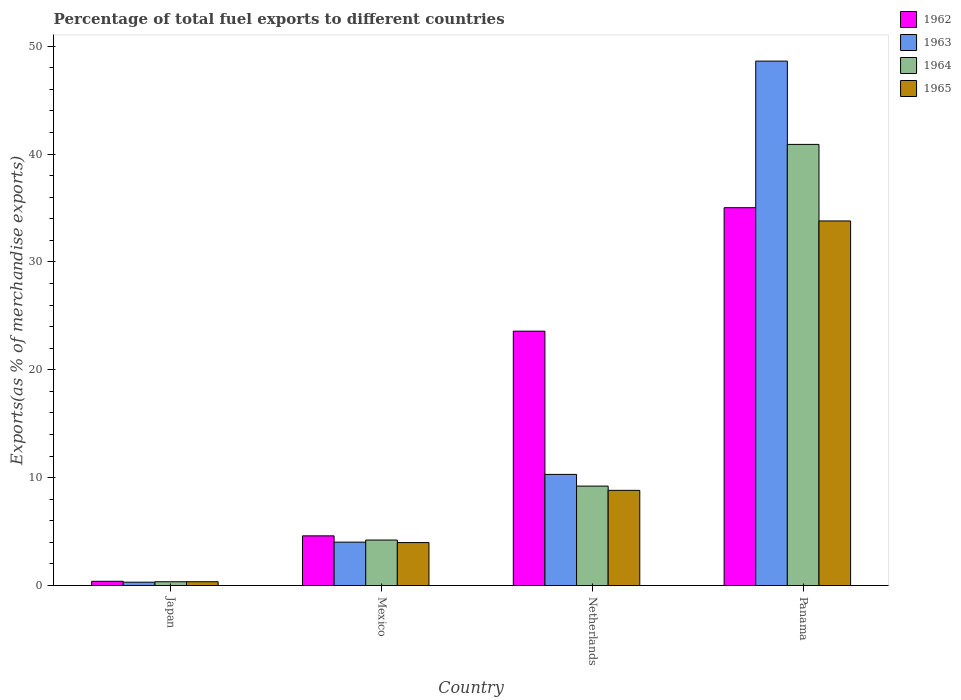How many groups of bars are there?
Offer a terse response. 4. Are the number of bars per tick equal to the number of legend labels?
Give a very brief answer. Yes. How many bars are there on the 3rd tick from the left?
Make the answer very short. 4. How many bars are there on the 4th tick from the right?
Keep it short and to the point. 4. What is the label of the 2nd group of bars from the left?
Your answer should be very brief. Mexico. What is the percentage of exports to different countries in 1965 in Panama?
Your answer should be compact. 33.8. Across all countries, what is the maximum percentage of exports to different countries in 1962?
Your response must be concise. 35.03. Across all countries, what is the minimum percentage of exports to different countries in 1962?
Offer a terse response. 0.4. In which country was the percentage of exports to different countries in 1965 maximum?
Ensure brevity in your answer.  Panama. What is the total percentage of exports to different countries in 1962 in the graph?
Offer a very short reply. 63.62. What is the difference between the percentage of exports to different countries in 1964 in Japan and that in Panama?
Provide a short and direct response. -40.54. What is the difference between the percentage of exports to different countries in 1965 in Japan and the percentage of exports to different countries in 1964 in Netherlands?
Provide a short and direct response. -8.86. What is the average percentage of exports to different countries in 1964 per country?
Make the answer very short. 13.67. What is the difference between the percentage of exports to different countries of/in 1964 and percentage of exports to different countries of/in 1962 in Panama?
Your answer should be very brief. 5.87. In how many countries, is the percentage of exports to different countries in 1963 greater than 22 %?
Your response must be concise. 1. What is the ratio of the percentage of exports to different countries in 1962 in Mexico to that in Netherlands?
Your answer should be compact. 0.2. Is the percentage of exports to different countries in 1965 in Japan less than that in Mexico?
Make the answer very short. Yes. Is the difference between the percentage of exports to different countries in 1964 in Japan and Netherlands greater than the difference between the percentage of exports to different countries in 1962 in Japan and Netherlands?
Your answer should be very brief. Yes. What is the difference between the highest and the second highest percentage of exports to different countries in 1962?
Make the answer very short. 30.42. What is the difference between the highest and the lowest percentage of exports to different countries in 1962?
Provide a succinct answer. 34.63. In how many countries, is the percentage of exports to different countries in 1963 greater than the average percentage of exports to different countries in 1963 taken over all countries?
Provide a short and direct response. 1. What does the 3rd bar from the left in Netherlands represents?
Give a very brief answer. 1964. What does the 4th bar from the right in Japan represents?
Provide a short and direct response. 1962. How many countries are there in the graph?
Your answer should be very brief. 4. Are the values on the major ticks of Y-axis written in scientific E-notation?
Offer a very short reply. No. Does the graph contain grids?
Provide a succinct answer. No. Where does the legend appear in the graph?
Make the answer very short. Top right. How many legend labels are there?
Your response must be concise. 4. How are the legend labels stacked?
Ensure brevity in your answer.  Vertical. What is the title of the graph?
Ensure brevity in your answer.  Percentage of total fuel exports to different countries. Does "2006" appear as one of the legend labels in the graph?
Provide a succinct answer. No. What is the label or title of the X-axis?
Offer a very short reply. Country. What is the label or title of the Y-axis?
Offer a very short reply. Exports(as % of merchandise exports). What is the Exports(as % of merchandise exports) of 1962 in Japan?
Keep it short and to the point. 0.4. What is the Exports(as % of merchandise exports) of 1963 in Japan?
Your answer should be compact. 0.31. What is the Exports(as % of merchandise exports) of 1964 in Japan?
Provide a short and direct response. 0.35. What is the Exports(as % of merchandise exports) in 1965 in Japan?
Offer a very short reply. 0.36. What is the Exports(as % of merchandise exports) of 1962 in Mexico?
Offer a very short reply. 4.61. What is the Exports(as % of merchandise exports) in 1963 in Mexico?
Offer a very short reply. 4.03. What is the Exports(as % of merchandise exports) of 1964 in Mexico?
Your answer should be very brief. 4.22. What is the Exports(as % of merchandise exports) of 1965 in Mexico?
Offer a terse response. 3.99. What is the Exports(as % of merchandise exports) in 1962 in Netherlands?
Ensure brevity in your answer.  23.58. What is the Exports(as % of merchandise exports) in 1963 in Netherlands?
Offer a very short reply. 10.31. What is the Exports(as % of merchandise exports) in 1964 in Netherlands?
Give a very brief answer. 9.22. What is the Exports(as % of merchandise exports) of 1965 in Netherlands?
Your answer should be compact. 8.83. What is the Exports(as % of merchandise exports) of 1962 in Panama?
Give a very brief answer. 35.03. What is the Exports(as % of merchandise exports) in 1963 in Panama?
Your response must be concise. 48.62. What is the Exports(as % of merchandise exports) of 1964 in Panama?
Your answer should be very brief. 40.9. What is the Exports(as % of merchandise exports) of 1965 in Panama?
Keep it short and to the point. 33.8. Across all countries, what is the maximum Exports(as % of merchandise exports) in 1962?
Your answer should be very brief. 35.03. Across all countries, what is the maximum Exports(as % of merchandise exports) in 1963?
Keep it short and to the point. 48.62. Across all countries, what is the maximum Exports(as % of merchandise exports) of 1964?
Offer a very short reply. 40.9. Across all countries, what is the maximum Exports(as % of merchandise exports) in 1965?
Ensure brevity in your answer.  33.8. Across all countries, what is the minimum Exports(as % of merchandise exports) of 1962?
Give a very brief answer. 0.4. Across all countries, what is the minimum Exports(as % of merchandise exports) of 1963?
Make the answer very short. 0.31. Across all countries, what is the minimum Exports(as % of merchandise exports) of 1964?
Offer a terse response. 0.35. Across all countries, what is the minimum Exports(as % of merchandise exports) of 1965?
Offer a terse response. 0.36. What is the total Exports(as % of merchandise exports) of 1962 in the graph?
Your answer should be very brief. 63.62. What is the total Exports(as % of merchandise exports) of 1963 in the graph?
Your answer should be compact. 63.26. What is the total Exports(as % of merchandise exports) of 1964 in the graph?
Offer a terse response. 54.69. What is the total Exports(as % of merchandise exports) of 1965 in the graph?
Give a very brief answer. 46.97. What is the difference between the Exports(as % of merchandise exports) of 1962 in Japan and that in Mexico?
Your response must be concise. -4.21. What is the difference between the Exports(as % of merchandise exports) in 1963 in Japan and that in Mexico?
Provide a succinct answer. -3.71. What is the difference between the Exports(as % of merchandise exports) of 1964 in Japan and that in Mexico?
Your answer should be compact. -3.87. What is the difference between the Exports(as % of merchandise exports) of 1965 in Japan and that in Mexico?
Keep it short and to the point. -3.63. What is the difference between the Exports(as % of merchandise exports) of 1962 in Japan and that in Netherlands?
Ensure brevity in your answer.  -23.19. What is the difference between the Exports(as % of merchandise exports) in 1963 in Japan and that in Netherlands?
Make the answer very short. -9.99. What is the difference between the Exports(as % of merchandise exports) in 1964 in Japan and that in Netherlands?
Your response must be concise. -8.87. What is the difference between the Exports(as % of merchandise exports) of 1965 in Japan and that in Netherlands?
Your answer should be very brief. -8.47. What is the difference between the Exports(as % of merchandise exports) of 1962 in Japan and that in Panama?
Offer a terse response. -34.63. What is the difference between the Exports(as % of merchandise exports) of 1963 in Japan and that in Panama?
Make the answer very short. -48.31. What is the difference between the Exports(as % of merchandise exports) in 1964 in Japan and that in Panama?
Your answer should be very brief. -40.54. What is the difference between the Exports(as % of merchandise exports) in 1965 in Japan and that in Panama?
Ensure brevity in your answer.  -33.45. What is the difference between the Exports(as % of merchandise exports) in 1962 in Mexico and that in Netherlands?
Your response must be concise. -18.97. What is the difference between the Exports(as % of merchandise exports) in 1963 in Mexico and that in Netherlands?
Your answer should be very brief. -6.28. What is the difference between the Exports(as % of merchandise exports) of 1964 in Mexico and that in Netherlands?
Provide a succinct answer. -5. What is the difference between the Exports(as % of merchandise exports) of 1965 in Mexico and that in Netherlands?
Give a very brief answer. -4.84. What is the difference between the Exports(as % of merchandise exports) in 1962 in Mexico and that in Panama?
Provide a short and direct response. -30.42. What is the difference between the Exports(as % of merchandise exports) in 1963 in Mexico and that in Panama?
Ensure brevity in your answer.  -44.59. What is the difference between the Exports(as % of merchandise exports) of 1964 in Mexico and that in Panama?
Make the answer very short. -36.68. What is the difference between the Exports(as % of merchandise exports) in 1965 in Mexico and that in Panama?
Offer a terse response. -29.82. What is the difference between the Exports(as % of merchandise exports) of 1962 in Netherlands and that in Panama?
Your answer should be very brief. -11.45. What is the difference between the Exports(as % of merchandise exports) of 1963 in Netherlands and that in Panama?
Ensure brevity in your answer.  -38.32. What is the difference between the Exports(as % of merchandise exports) of 1964 in Netherlands and that in Panama?
Your response must be concise. -31.68. What is the difference between the Exports(as % of merchandise exports) of 1965 in Netherlands and that in Panama?
Offer a terse response. -24.98. What is the difference between the Exports(as % of merchandise exports) in 1962 in Japan and the Exports(as % of merchandise exports) in 1963 in Mexico?
Provide a short and direct response. -3.63. What is the difference between the Exports(as % of merchandise exports) of 1962 in Japan and the Exports(as % of merchandise exports) of 1964 in Mexico?
Make the answer very short. -3.82. What is the difference between the Exports(as % of merchandise exports) in 1962 in Japan and the Exports(as % of merchandise exports) in 1965 in Mexico?
Your answer should be very brief. -3.59. What is the difference between the Exports(as % of merchandise exports) of 1963 in Japan and the Exports(as % of merchandise exports) of 1964 in Mexico?
Provide a succinct answer. -3.91. What is the difference between the Exports(as % of merchandise exports) in 1963 in Japan and the Exports(as % of merchandise exports) in 1965 in Mexico?
Your answer should be compact. -3.67. What is the difference between the Exports(as % of merchandise exports) of 1964 in Japan and the Exports(as % of merchandise exports) of 1965 in Mexico?
Provide a short and direct response. -3.63. What is the difference between the Exports(as % of merchandise exports) of 1962 in Japan and the Exports(as % of merchandise exports) of 1963 in Netherlands?
Make the answer very short. -9.91. What is the difference between the Exports(as % of merchandise exports) in 1962 in Japan and the Exports(as % of merchandise exports) in 1964 in Netherlands?
Provide a short and direct response. -8.82. What is the difference between the Exports(as % of merchandise exports) in 1962 in Japan and the Exports(as % of merchandise exports) in 1965 in Netherlands?
Ensure brevity in your answer.  -8.43. What is the difference between the Exports(as % of merchandise exports) in 1963 in Japan and the Exports(as % of merchandise exports) in 1964 in Netherlands?
Keep it short and to the point. -8.91. What is the difference between the Exports(as % of merchandise exports) of 1963 in Japan and the Exports(as % of merchandise exports) of 1965 in Netherlands?
Make the answer very short. -8.51. What is the difference between the Exports(as % of merchandise exports) in 1964 in Japan and the Exports(as % of merchandise exports) in 1965 in Netherlands?
Ensure brevity in your answer.  -8.47. What is the difference between the Exports(as % of merchandise exports) of 1962 in Japan and the Exports(as % of merchandise exports) of 1963 in Panama?
Provide a short and direct response. -48.22. What is the difference between the Exports(as % of merchandise exports) in 1962 in Japan and the Exports(as % of merchandise exports) in 1964 in Panama?
Provide a succinct answer. -40.5. What is the difference between the Exports(as % of merchandise exports) in 1962 in Japan and the Exports(as % of merchandise exports) in 1965 in Panama?
Make the answer very short. -33.41. What is the difference between the Exports(as % of merchandise exports) of 1963 in Japan and the Exports(as % of merchandise exports) of 1964 in Panama?
Offer a very short reply. -40.58. What is the difference between the Exports(as % of merchandise exports) of 1963 in Japan and the Exports(as % of merchandise exports) of 1965 in Panama?
Offer a very short reply. -33.49. What is the difference between the Exports(as % of merchandise exports) of 1964 in Japan and the Exports(as % of merchandise exports) of 1965 in Panama?
Offer a terse response. -33.45. What is the difference between the Exports(as % of merchandise exports) of 1962 in Mexico and the Exports(as % of merchandise exports) of 1963 in Netherlands?
Give a very brief answer. -5.7. What is the difference between the Exports(as % of merchandise exports) in 1962 in Mexico and the Exports(as % of merchandise exports) in 1964 in Netherlands?
Keep it short and to the point. -4.61. What is the difference between the Exports(as % of merchandise exports) in 1962 in Mexico and the Exports(as % of merchandise exports) in 1965 in Netherlands?
Your response must be concise. -4.22. What is the difference between the Exports(as % of merchandise exports) of 1963 in Mexico and the Exports(as % of merchandise exports) of 1964 in Netherlands?
Ensure brevity in your answer.  -5.19. What is the difference between the Exports(as % of merchandise exports) of 1963 in Mexico and the Exports(as % of merchandise exports) of 1965 in Netherlands?
Offer a terse response. -4.8. What is the difference between the Exports(as % of merchandise exports) in 1964 in Mexico and the Exports(as % of merchandise exports) in 1965 in Netherlands?
Ensure brevity in your answer.  -4.61. What is the difference between the Exports(as % of merchandise exports) of 1962 in Mexico and the Exports(as % of merchandise exports) of 1963 in Panama?
Ensure brevity in your answer.  -44.01. What is the difference between the Exports(as % of merchandise exports) of 1962 in Mexico and the Exports(as % of merchandise exports) of 1964 in Panama?
Your answer should be very brief. -36.29. What is the difference between the Exports(as % of merchandise exports) in 1962 in Mexico and the Exports(as % of merchandise exports) in 1965 in Panama?
Provide a short and direct response. -29.19. What is the difference between the Exports(as % of merchandise exports) in 1963 in Mexico and the Exports(as % of merchandise exports) in 1964 in Panama?
Your response must be concise. -36.87. What is the difference between the Exports(as % of merchandise exports) of 1963 in Mexico and the Exports(as % of merchandise exports) of 1965 in Panama?
Offer a very short reply. -29.78. What is the difference between the Exports(as % of merchandise exports) of 1964 in Mexico and the Exports(as % of merchandise exports) of 1965 in Panama?
Offer a terse response. -29.58. What is the difference between the Exports(as % of merchandise exports) in 1962 in Netherlands and the Exports(as % of merchandise exports) in 1963 in Panama?
Provide a succinct answer. -25.04. What is the difference between the Exports(as % of merchandise exports) in 1962 in Netherlands and the Exports(as % of merchandise exports) in 1964 in Panama?
Provide a short and direct response. -17.31. What is the difference between the Exports(as % of merchandise exports) in 1962 in Netherlands and the Exports(as % of merchandise exports) in 1965 in Panama?
Offer a very short reply. -10.22. What is the difference between the Exports(as % of merchandise exports) in 1963 in Netherlands and the Exports(as % of merchandise exports) in 1964 in Panama?
Your answer should be very brief. -30.59. What is the difference between the Exports(as % of merchandise exports) of 1963 in Netherlands and the Exports(as % of merchandise exports) of 1965 in Panama?
Your answer should be very brief. -23.5. What is the difference between the Exports(as % of merchandise exports) in 1964 in Netherlands and the Exports(as % of merchandise exports) in 1965 in Panama?
Ensure brevity in your answer.  -24.58. What is the average Exports(as % of merchandise exports) of 1962 per country?
Your answer should be very brief. 15.9. What is the average Exports(as % of merchandise exports) of 1963 per country?
Your answer should be very brief. 15.82. What is the average Exports(as % of merchandise exports) in 1964 per country?
Offer a terse response. 13.67. What is the average Exports(as % of merchandise exports) of 1965 per country?
Your response must be concise. 11.74. What is the difference between the Exports(as % of merchandise exports) in 1962 and Exports(as % of merchandise exports) in 1963 in Japan?
Provide a short and direct response. 0.08. What is the difference between the Exports(as % of merchandise exports) in 1962 and Exports(as % of merchandise exports) in 1964 in Japan?
Your response must be concise. 0.04. What is the difference between the Exports(as % of merchandise exports) in 1962 and Exports(as % of merchandise exports) in 1965 in Japan?
Keep it short and to the point. 0.04. What is the difference between the Exports(as % of merchandise exports) of 1963 and Exports(as % of merchandise exports) of 1964 in Japan?
Ensure brevity in your answer.  -0.04. What is the difference between the Exports(as % of merchandise exports) of 1963 and Exports(as % of merchandise exports) of 1965 in Japan?
Offer a terse response. -0.04. What is the difference between the Exports(as % of merchandise exports) of 1964 and Exports(as % of merchandise exports) of 1965 in Japan?
Ensure brevity in your answer.  -0. What is the difference between the Exports(as % of merchandise exports) in 1962 and Exports(as % of merchandise exports) in 1963 in Mexico?
Offer a terse response. 0.58. What is the difference between the Exports(as % of merchandise exports) in 1962 and Exports(as % of merchandise exports) in 1964 in Mexico?
Your response must be concise. 0.39. What is the difference between the Exports(as % of merchandise exports) in 1962 and Exports(as % of merchandise exports) in 1965 in Mexico?
Offer a very short reply. 0.62. What is the difference between the Exports(as % of merchandise exports) of 1963 and Exports(as % of merchandise exports) of 1964 in Mexico?
Make the answer very short. -0.19. What is the difference between the Exports(as % of merchandise exports) in 1963 and Exports(as % of merchandise exports) in 1965 in Mexico?
Offer a very short reply. 0.04. What is the difference between the Exports(as % of merchandise exports) in 1964 and Exports(as % of merchandise exports) in 1965 in Mexico?
Your answer should be very brief. 0.23. What is the difference between the Exports(as % of merchandise exports) in 1962 and Exports(as % of merchandise exports) in 1963 in Netherlands?
Offer a terse response. 13.28. What is the difference between the Exports(as % of merchandise exports) of 1962 and Exports(as % of merchandise exports) of 1964 in Netherlands?
Provide a short and direct response. 14.36. What is the difference between the Exports(as % of merchandise exports) in 1962 and Exports(as % of merchandise exports) in 1965 in Netherlands?
Ensure brevity in your answer.  14.76. What is the difference between the Exports(as % of merchandise exports) of 1963 and Exports(as % of merchandise exports) of 1964 in Netherlands?
Make the answer very short. 1.09. What is the difference between the Exports(as % of merchandise exports) in 1963 and Exports(as % of merchandise exports) in 1965 in Netherlands?
Keep it short and to the point. 1.48. What is the difference between the Exports(as % of merchandise exports) of 1964 and Exports(as % of merchandise exports) of 1965 in Netherlands?
Your response must be concise. 0.39. What is the difference between the Exports(as % of merchandise exports) in 1962 and Exports(as % of merchandise exports) in 1963 in Panama?
Your answer should be very brief. -13.59. What is the difference between the Exports(as % of merchandise exports) of 1962 and Exports(as % of merchandise exports) of 1964 in Panama?
Your answer should be compact. -5.87. What is the difference between the Exports(as % of merchandise exports) of 1962 and Exports(as % of merchandise exports) of 1965 in Panama?
Give a very brief answer. 1.23. What is the difference between the Exports(as % of merchandise exports) of 1963 and Exports(as % of merchandise exports) of 1964 in Panama?
Your answer should be compact. 7.72. What is the difference between the Exports(as % of merchandise exports) of 1963 and Exports(as % of merchandise exports) of 1965 in Panama?
Ensure brevity in your answer.  14.82. What is the difference between the Exports(as % of merchandise exports) of 1964 and Exports(as % of merchandise exports) of 1965 in Panama?
Your response must be concise. 7.1. What is the ratio of the Exports(as % of merchandise exports) in 1962 in Japan to that in Mexico?
Provide a succinct answer. 0.09. What is the ratio of the Exports(as % of merchandise exports) of 1963 in Japan to that in Mexico?
Provide a succinct answer. 0.08. What is the ratio of the Exports(as % of merchandise exports) in 1964 in Japan to that in Mexico?
Give a very brief answer. 0.08. What is the ratio of the Exports(as % of merchandise exports) of 1965 in Japan to that in Mexico?
Keep it short and to the point. 0.09. What is the ratio of the Exports(as % of merchandise exports) of 1962 in Japan to that in Netherlands?
Your answer should be very brief. 0.02. What is the ratio of the Exports(as % of merchandise exports) of 1963 in Japan to that in Netherlands?
Provide a short and direct response. 0.03. What is the ratio of the Exports(as % of merchandise exports) in 1964 in Japan to that in Netherlands?
Ensure brevity in your answer.  0.04. What is the ratio of the Exports(as % of merchandise exports) in 1965 in Japan to that in Netherlands?
Offer a very short reply. 0.04. What is the ratio of the Exports(as % of merchandise exports) of 1962 in Japan to that in Panama?
Keep it short and to the point. 0.01. What is the ratio of the Exports(as % of merchandise exports) in 1963 in Japan to that in Panama?
Offer a terse response. 0.01. What is the ratio of the Exports(as % of merchandise exports) of 1964 in Japan to that in Panama?
Offer a terse response. 0.01. What is the ratio of the Exports(as % of merchandise exports) of 1965 in Japan to that in Panama?
Your response must be concise. 0.01. What is the ratio of the Exports(as % of merchandise exports) of 1962 in Mexico to that in Netherlands?
Make the answer very short. 0.2. What is the ratio of the Exports(as % of merchandise exports) in 1963 in Mexico to that in Netherlands?
Give a very brief answer. 0.39. What is the ratio of the Exports(as % of merchandise exports) in 1964 in Mexico to that in Netherlands?
Offer a terse response. 0.46. What is the ratio of the Exports(as % of merchandise exports) in 1965 in Mexico to that in Netherlands?
Ensure brevity in your answer.  0.45. What is the ratio of the Exports(as % of merchandise exports) of 1962 in Mexico to that in Panama?
Provide a succinct answer. 0.13. What is the ratio of the Exports(as % of merchandise exports) of 1963 in Mexico to that in Panama?
Give a very brief answer. 0.08. What is the ratio of the Exports(as % of merchandise exports) in 1964 in Mexico to that in Panama?
Provide a succinct answer. 0.1. What is the ratio of the Exports(as % of merchandise exports) in 1965 in Mexico to that in Panama?
Provide a short and direct response. 0.12. What is the ratio of the Exports(as % of merchandise exports) of 1962 in Netherlands to that in Panama?
Your answer should be very brief. 0.67. What is the ratio of the Exports(as % of merchandise exports) in 1963 in Netherlands to that in Panama?
Provide a short and direct response. 0.21. What is the ratio of the Exports(as % of merchandise exports) of 1964 in Netherlands to that in Panama?
Ensure brevity in your answer.  0.23. What is the ratio of the Exports(as % of merchandise exports) of 1965 in Netherlands to that in Panama?
Give a very brief answer. 0.26. What is the difference between the highest and the second highest Exports(as % of merchandise exports) in 1962?
Make the answer very short. 11.45. What is the difference between the highest and the second highest Exports(as % of merchandise exports) in 1963?
Your answer should be compact. 38.32. What is the difference between the highest and the second highest Exports(as % of merchandise exports) in 1964?
Offer a terse response. 31.68. What is the difference between the highest and the second highest Exports(as % of merchandise exports) of 1965?
Your answer should be very brief. 24.98. What is the difference between the highest and the lowest Exports(as % of merchandise exports) in 1962?
Offer a very short reply. 34.63. What is the difference between the highest and the lowest Exports(as % of merchandise exports) of 1963?
Your answer should be compact. 48.31. What is the difference between the highest and the lowest Exports(as % of merchandise exports) of 1964?
Your answer should be very brief. 40.54. What is the difference between the highest and the lowest Exports(as % of merchandise exports) of 1965?
Offer a very short reply. 33.45. 